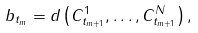Convert formula to latex. <formula><loc_0><loc_0><loc_500><loc_500>b _ { t _ { m } } = d \left ( C ^ { 1 } _ { t _ { m + 1 } } , \dots , C ^ { N } _ { t _ { m + 1 } } \right ) ,</formula> 